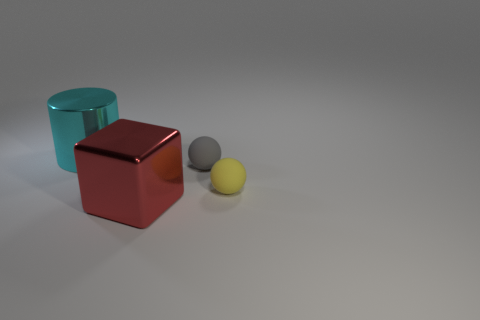How many things are big shiny things that are behind the small gray matte sphere or yellow rubber objects?
Your answer should be compact. 2. There is a big object that is behind the big metallic object in front of the gray sphere; what is its shape?
Your response must be concise. Cylinder. Are there any other cylinders of the same size as the shiny cylinder?
Provide a short and direct response. No. Is the number of big brown matte cubes greater than the number of big red shiny things?
Make the answer very short. No. Do the cyan metal thing that is behind the small yellow rubber object and the object that is right of the gray matte object have the same size?
Ensure brevity in your answer.  No. What number of things are both in front of the small gray object and to the left of the yellow sphere?
Ensure brevity in your answer.  1. What color is the other object that is the same shape as the yellow thing?
Offer a very short reply. Gray. Are there fewer small brown matte cubes than tiny spheres?
Keep it short and to the point. Yes. Is the size of the block the same as the shiny cylinder on the left side of the red metallic cube?
Keep it short and to the point. Yes. The large metallic thing that is left of the big red metallic object in front of the cyan shiny cylinder is what color?
Provide a short and direct response. Cyan. 